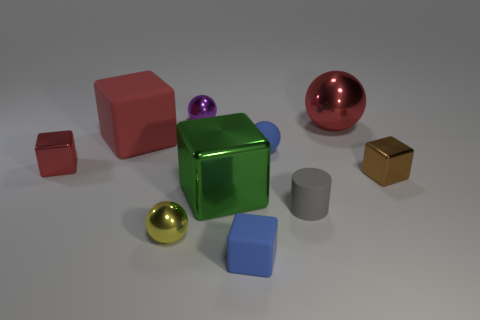There is a tiny cube that is the same color as the big rubber object; what material is it?
Keep it short and to the point. Metal. What number of other objects are there of the same material as the green object?
Provide a short and direct response. 5. There is a thing that is right of the large metal cube and in front of the gray rubber cylinder; what shape is it?
Make the answer very short. Cube. There is a big cube that is the same material as the brown object; what color is it?
Offer a terse response. Green. Are there an equal number of small rubber blocks that are behind the small purple object and small brown metal objects?
Your answer should be very brief. No. What shape is the purple metallic thing that is the same size as the gray matte object?
Ensure brevity in your answer.  Sphere. How many other objects are the same shape as the large red matte object?
Keep it short and to the point. 4. Does the purple object have the same size as the matte block that is behind the small red thing?
Your response must be concise. No. How many objects are either big cubes that are behind the large metallic cube or tiny purple spheres?
Offer a terse response. 2. There is a small blue object behind the small red block; what shape is it?
Make the answer very short. Sphere. 